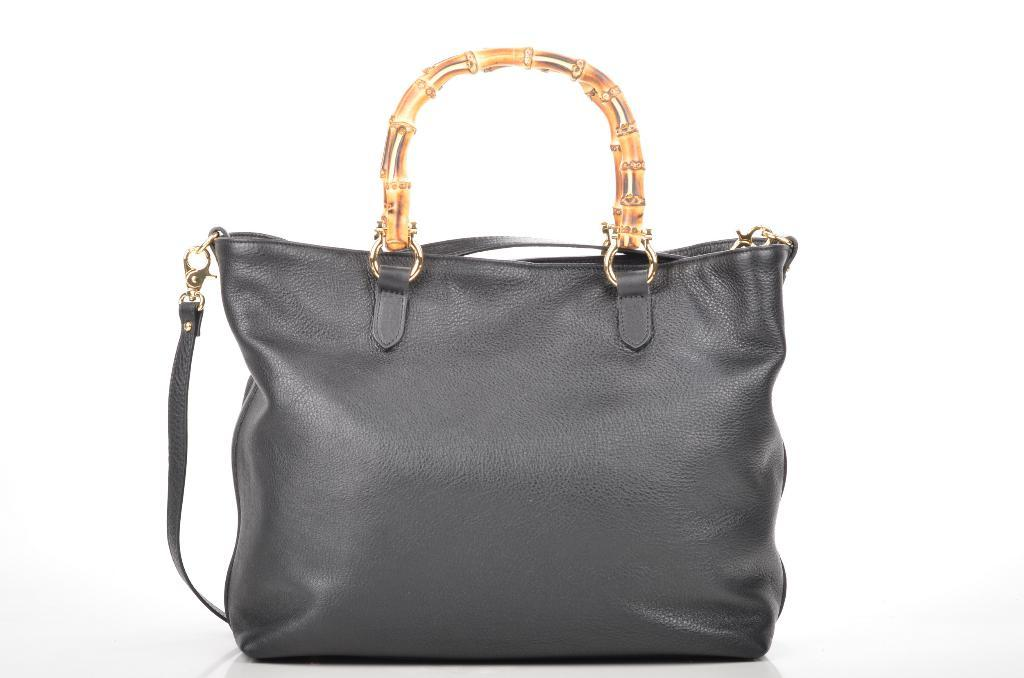What type of accessory is present in the image? There is a purse in the image. Can you describe the color of the purse? The purse is ash-colored. What is the color of the handle on the purse? The handle of the purse is golden-colored. What type of instrument is being played in the image? There is no instrument present in the image; it only features a purse. How does the purse control the flow of information in the image? The purse does not control the flow of information in the image, as it is an inanimate object. 